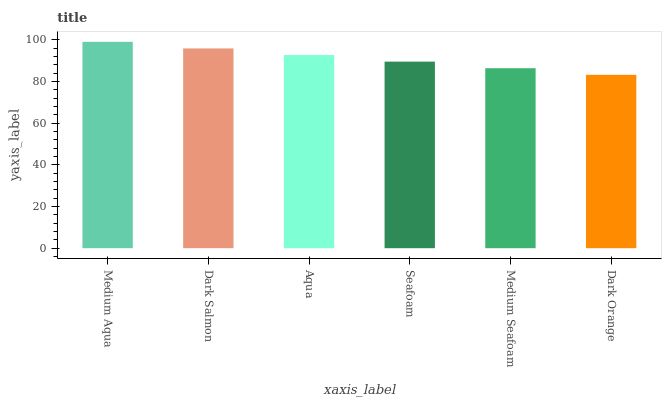Is Dark Orange the minimum?
Answer yes or no. Yes. Is Medium Aqua the maximum?
Answer yes or no. Yes. Is Dark Salmon the minimum?
Answer yes or no. No. Is Dark Salmon the maximum?
Answer yes or no. No. Is Medium Aqua greater than Dark Salmon?
Answer yes or no. Yes. Is Dark Salmon less than Medium Aqua?
Answer yes or no. Yes. Is Dark Salmon greater than Medium Aqua?
Answer yes or no. No. Is Medium Aqua less than Dark Salmon?
Answer yes or no. No. Is Aqua the high median?
Answer yes or no. Yes. Is Seafoam the low median?
Answer yes or no. Yes. Is Dark Orange the high median?
Answer yes or no. No. Is Medium Seafoam the low median?
Answer yes or no. No. 